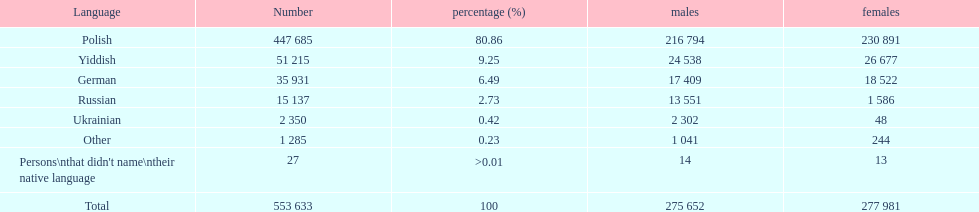How many speakers (of any language) are represented on the table ? 553 633. 